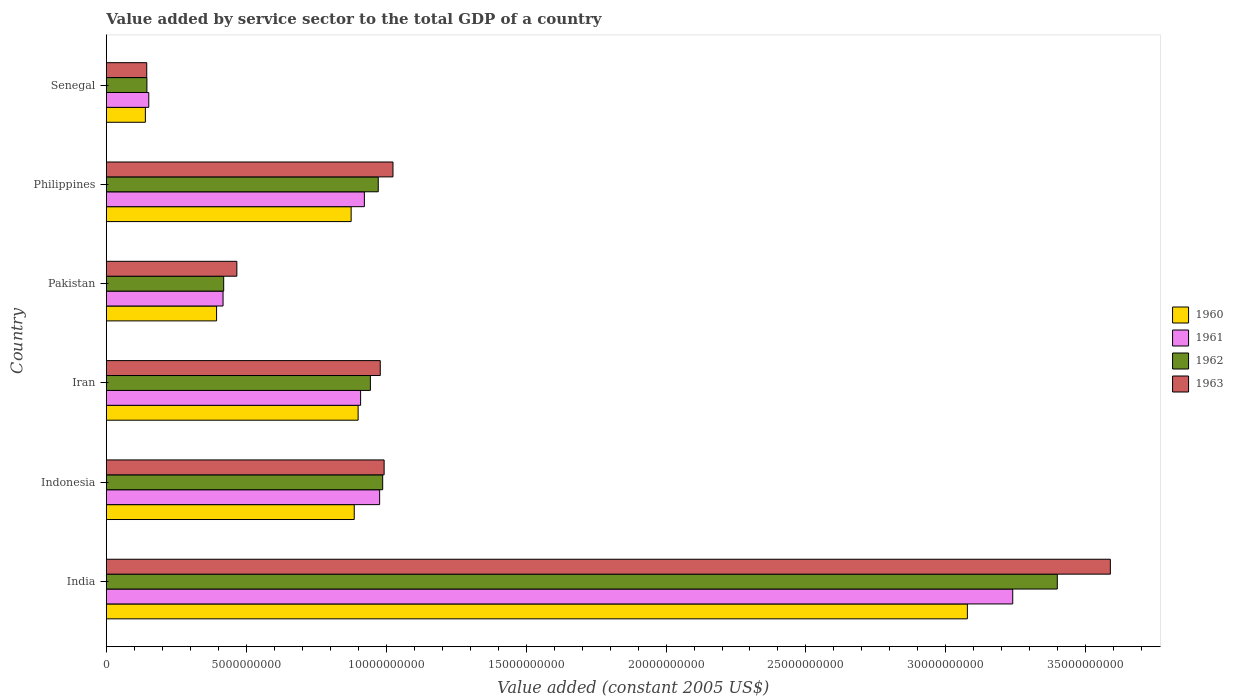How many different coloured bars are there?
Your answer should be compact. 4. How many groups of bars are there?
Provide a short and direct response. 6. How many bars are there on the 6th tick from the top?
Keep it short and to the point. 4. What is the value added by service sector in 1962 in Philippines?
Your response must be concise. 9.72e+09. Across all countries, what is the maximum value added by service sector in 1960?
Offer a very short reply. 3.08e+1. Across all countries, what is the minimum value added by service sector in 1962?
Provide a succinct answer. 1.45e+09. In which country was the value added by service sector in 1963 minimum?
Provide a succinct answer. Senegal. What is the total value added by service sector in 1961 in the graph?
Make the answer very short. 6.62e+1. What is the difference between the value added by service sector in 1960 in Iran and that in Philippines?
Provide a succinct answer. 2.49e+08. What is the difference between the value added by service sector in 1963 in India and the value added by service sector in 1961 in Pakistan?
Offer a very short reply. 3.17e+1. What is the average value added by service sector in 1962 per country?
Your response must be concise. 1.14e+1. What is the difference between the value added by service sector in 1962 and value added by service sector in 1963 in Iran?
Give a very brief answer. -3.52e+08. In how many countries, is the value added by service sector in 1962 greater than 2000000000 US$?
Offer a very short reply. 5. What is the ratio of the value added by service sector in 1961 in Philippines to that in Senegal?
Provide a short and direct response. 6.08. What is the difference between the highest and the second highest value added by service sector in 1961?
Make the answer very short. 2.26e+1. What is the difference between the highest and the lowest value added by service sector in 1962?
Your response must be concise. 3.25e+1. Is it the case that in every country, the sum of the value added by service sector in 1963 and value added by service sector in 1960 is greater than the value added by service sector in 1961?
Your response must be concise. Yes. What is the difference between two consecutive major ticks on the X-axis?
Ensure brevity in your answer.  5.00e+09. Does the graph contain grids?
Give a very brief answer. No. How many legend labels are there?
Your response must be concise. 4. What is the title of the graph?
Your answer should be compact. Value added by service sector to the total GDP of a country. Does "2004" appear as one of the legend labels in the graph?
Give a very brief answer. No. What is the label or title of the X-axis?
Offer a terse response. Value added (constant 2005 US$). What is the label or title of the Y-axis?
Offer a very short reply. Country. What is the Value added (constant 2005 US$) of 1960 in India?
Give a very brief answer. 3.08e+1. What is the Value added (constant 2005 US$) of 1961 in India?
Provide a succinct answer. 3.24e+1. What is the Value added (constant 2005 US$) in 1962 in India?
Provide a short and direct response. 3.40e+1. What is the Value added (constant 2005 US$) of 1963 in India?
Provide a succinct answer. 3.59e+1. What is the Value added (constant 2005 US$) of 1960 in Indonesia?
Offer a very short reply. 8.86e+09. What is the Value added (constant 2005 US$) of 1961 in Indonesia?
Your response must be concise. 9.77e+09. What is the Value added (constant 2005 US$) of 1962 in Indonesia?
Ensure brevity in your answer.  9.88e+09. What is the Value added (constant 2005 US$) of 1963 in Indonesia?
Provide a succinct answer. 9.93e+09. What is the Value added (constant 2005 US$) in 1960 in Iran?
Your answer should be very brief. 9.00e+09. What is the Value added (constant 2005 US$) in 1961 in Iran?
Offer a terse response. 9.09e+09. What is the Value added (constant 2005 US$) of 1962 in Iran?
Give a very brief answer. 9.44e+09. What is the Value added (constant 2005 US$) in 1963 in Iran?
Keep it short and to the point. 9.79e+09. What is the Value added (constant 2005 US$) in 1960 in Pakistan?
Keep it short and to the point. 3.94e+09. What is the Value added (constant 2005 US$) of 1961 in Pakistan?
Give a very brief answer. 4.17e+09. What is the Value added (constant 2005 US$) of 1962 in Pakistan?
Your answer should be compact. 4.19e+09. What is the Value added (constant 2005 US$) of 1963 in Pakistan?
Keep it short and to the point. 4.66e+09. What is the Value added (constant 2005 US$) of 1960 in Philippines?
Offer a very short reply. 8.75e+09. What is the Value added (constant 2005 US$) of 1961 in Philippines?
Ensure brevity in your answer.  9.22e+09. What is the Value added (constant 2005 US$) in 1962 in Philippines?
Offer a very short reply. 9.72e+09. What is the Value added (constant 2005 US$) of 1963 in Philippines?
Offer a terse response. 1.02e+1. What is the Value added (constant 2005 US$) in 1960 in Senegal?
Ensure brevity in your answer.  1.39e+09. What is the Value added (constant 2005 US$) in 1961 in Senegal?
Offer a terse response. 1.52e+09. What is the Value added (constant 2005 US$) in 1962 in Senegal?
Keep it short and to the point. 1.45e+09. What is the Value added (constant 2005 US$) in 1963 in Senegal?
Provide a succinct answer. 1.44e+09. Across all countries, what is the maximum Value added (constant 2005 US$) in 1960?
Make the answer very short. 3.08e+1. Across all countries, what is the maximum Value added (constant 2005 US$) of 1961?
Offer a very short reply. 3.24e+1. Across all countries, what is the maximum Value added (constant 2005 US$) in 1962?
Your response must be concise. 3.40e+1. Across all countries, what is the maximum Value added (constant 2005 US$) of 1963?
Make the answer very short. 3.59e+1. Across all countries, what is the minimum Value added (constant 2005 US$) in 1960?
Provide a succinct answer. 1.39e+09. Across all countries, what is the minimum Value added (constant 2005 US$) in 1961?
Ensure brevity in your answer.  1.52e+09. Across all countries, what is the minimum Value added (constant 2005 US$) of 1962?
Your answer should be compact. 1.45e+09. Across all countries, what is the minimum Value added (constant 2005 US$) in 1963?
Your answer should be compact. 1.44e+09. What is the total Value added (constant 2005 US$) of 1960 in the graph?
Offer a very short reply. 6.27e+1. What is the total Value added (constant 2005 US$) in 1961 in the graph?
Provide a succinct answer. 6.62e+1. What is the total Value added (constant 2005 US$) in 1962 in the graph?
Your answer should be very brief. 6.87e+1. What is the total Value added (constant 2005 US$) of 1963 in the graph?
Offer a terse response. 7.19e+1. What is the difference between the Value added (constant 2005 US$) in 1960 in India and that in Indonesia?
Your answer should be compact. 2.19e+1. What is the difference between the Value added (constant 2005 US$) in 1961 in India and that in Indonesia?
Your answer should be very brief. 2.26e+1. What is the difference between the Value added (constant 2005 US$) in 1962 in India and that in Indonesia?
Provide a succinct answer. 2.41e+1. What is the difference between the Value added (constant 2005 US$) in 1963 in India and that in Indonesia?
Provide a short and direct response. 2.60e+1. What is the difference between the Value added (constant 2005 US$) of 1960 in India and that in Iran?
Keep it short and to the point. 2.18e+1. What is the difference between the Value added (constant 2005 US$) of 1961 in India and that in Iran?
Your response must be concise. 2.33e+1. What is the difference between the Value added (constant 2005 US$) of 1962 in India and that in Iran?
Offer a very short reply. 2.45e+1. What is the difference between the Value added (constant 2005 US$) in 1963 in India and that in Iran?
Make the answer very short. 2.61e+1. What is the difference between the Value added (constant 2005 US$) of 1960 in India and that in Pakistan?
Your answer should be very brief. 2.68e+1. What is the difference between the Value added (constant 2005 US$) of 1961 in India and that in Pakistan?
Offer a very short reply. 2.82e+1. What is the difference between the Value added (constant 2005 US$) of 1962 in India and that in Pakistan?
Provide a succinct answer. 2.98e+1. What is the difference between the Value added (constant 2005 US$) in 1963 in India and that in Pakistan?
Offer a terse response. 3.12e+1. What is the difference between the Value added (constant 2005 US$) in 1960 in India and that in Philippines?
Your response must be concise. 2.20e+1. What is the difference between the Value added (constant 2005 US$) of 1961 in India and that in Philippines?
Your answer should be very brief. 2.32e+1. What is the difference between the Value added (constant 2005 US$) of 1962 in India and that in Philippines?
Ensure brevity in your answer.  2.43e+1. What is the difference between the Value added (constant 2005 US$) of 1963 in India and that in Philippines?
Provide a succinct answer. 2.56e+1. What is the difference between the Value added (constant 2005 US$) in 1960 in India and that in Senegal?
Offer a very short reply. 2.94e+1. What is the difference between the Value added (constant 2005 US$) in 1961 in India and that in Senegal?
Your answer should be very brief. 3.09e+1. What is the difference between the Value added (constant 2005 US$) in 1962 in India and that in Senegal?
Your response must be concise. 3.25e+1. What is the difference between the Value added (constant 2005 US$) in 1963 in India and that in Senegal?
Your answer should be compact. 3.44e+1. What is the difference between the Value added (constant 2005 US$) of 1960 in Indonesia and that in Iran?
Offer a very short reply. -1.39e+08. What is the difference between the Value added (constant 2005 US$) in 1961 in Indonesia and that in Iran?
Offer a very short reply. 6.80e+08. What is the difference between the Value added (constant 2005 US$) in 1962 in Indonesia and that in Iran?
Ensure brevity in your answer.  4.39e+08. What is the difference between the Value added (constant 2005 US$) in 1963 in Indonesia and that in Iran?
Your response must be concise. 1.38e+08. What is the difference between the Value added (constant 2005 US$) in 1960 in Indonesia and that in Pakistan?
Keep it short and to the point. 4.92e+09. What is the difference between the Value added (constant 2005 US$) in 1961 in Indonesia and that in Pakistan?
Your answer should be very brief. 5.60e+09. What is the difference between the Value added (constant 2005 US$) in 1962 in Indonesia and that in Pakistan?
Your answer should be very brief. 5.68e+09. What is the difference between the Value added (constant 2005 US$) of 1963 in Indonesia and that in Pakistan?
Ensure brevity in your answer.  5.26e+09. What is the difference between the Value added (constant 2005 US$) in 1960 in Indonesia and that in Philippines?
Your answer should be compact. 1.10e+08. What is the difference between the Value added (constant 2005 US$) in 1961 in Indonesia and that in Philippines?
Ensure brevity in your answer.  5.45e+08. What is the difference between the Value added (constant 2005 US$) of 1962 in Indonesia and that in Philippines?
Offer a terse response. 1.59e+08. What is the difference between the Value added (constant 2005 US$) of 1963 in Indonesia and that in Philippines?
Keep it short and to the point. -3.16e+08. What is the difference between the Value added (constant 2005 US$) in 1960 in Indonesia and that in Senegal?
Your response must be concise. 7.46e+09. What is the difference between the Value added (constant 2005 US$) in 1961 in Indonesia and that in Senegal?
Give a very brief answer. 8.25e+09. What is the difference between the Value added (constant 2005 US$) of 1962 in Indonesia and that in Senegal?
Provide a succinct answer. 8.43e+09. What is the difference between the Value added (constant 2005 US$) of 1963 in Indonesia and that in Senegal?
Your answer should be compact. 8.48e+09. What is the difference between the Value added (constant 2005 US$) in 1960 in Iran and that in Pakistan?
Offer a terse response. 5.06e+09. What is the difference between the Value added (constant 2005 US$) in 1961 in Iran and that in Pakistan?
Provide a succinct answer. 4.92e+09. What is the difference between the Value added (constant 2005 US$) of 1962 in Iran and that in Pakistan?
Offer a very short reply. 5.24e+09. What is the difference between the Value added (constant 2005 US$) of 1963 in Iran and that in Pakistan?
Provide a succinct answer. 5.12e+09. What is the difference between the Value added (constant 2005 US$) of 1960 in Iran and that in Philippines?
Your response must be concise. 2.49e+08. What is the difference between the Value added (constant 2005 US$) of 1961 in Iran and that in Philippines?
Your response must be concise. -1.35e+08. What is the difference between the Value added (constant 2005 US$) of 1962 in Iran and that in Philippines?
Offer a terse response. -2.80e+08. What is the difference between the Value added (constant 2005 US$) in 1963 in Iran and that in Philippines?
Offer a terse response. -4.54e+08. What is the difference between the Value added (constant 2005 US$) in 1960 in Iran and that in Senegal?
Keep it short and to the point. 7.60e+09. What is the difference between the Value added (constant 2005 US$) in 1961 in Iran and that in Senegal?
Provide a short and direct response. 7.57e+09. What is the difference between the Value added (constant 2005 US$) in 1962 in Iran and that in Senegal?
Keep it short and to the point. 7.99e+09. What is the difference between the Value added (constant 2005 US$) in 1963 in Iran and that in Senegal?
Offer a very short reply. 8.34e+09. What is the difference between the Value added (constant 2005 US$) in 1960 in Pakistan and that in Philippines?
Ensure brevity in your answer.  -4.81e+09. What is the difference between the Value added (constant 2005 US$) of 1961 in Pakistan and that in Philippines?
Provide a short and direct response. -5.05e+09. What is the difference between the Value added (constant 2005 US$) in 1962 in Pakistan and that in Philippines?
Your answer should be compact. -5.52e+09. What is the difference between the Value added (constant 2005 US$) in 1963 in Pakistan and that in Philippines?
Give a very brief answer. -5.58e+09. What is the difference between the Value added (constant 2005 US$) in 1960 in Pakistan and that in Senegal?
Provide a short and direct response. 2.54e+09. What is the difference between the Value added (constant 2005 US$) of 1961 in Pakistan and that in Senegal?
Offer a very short reply. 2.65e+09. What is the difference between the Value added (constant 2005 US$) in 1962 in Pakistan and that in Senegal?
Offer a very short reply. 2.74e+09. What is the difference between the Value added (constant 2005 US$) in 1963 in Pakistan and that in Senegal?
Your answer should be very brief. 3.22e+09. What is the difference between the Value added (constant 2005 US$) of 1960 in Philippines and that in Senegal?
Your answer should be compact. 7.35e+09. What is the difference between the Value added (constant 2005 US$) of 1961 in Philippines and that in Senegal?
Your response must be concise. 7.70e+09. What is the difference between the Value added (constant 2005 US$) of 1962 in Philippines and that in Senegal?
Ensure brevity in your answer.  8.27e+09. What is the difference between the Value added (constant 2005 US$) in 1963 in Philippines and that in Senegal?
Offer a terse response. 8.80e+09. What is the difference between the Value added (constant 2005 US$) in 1960 in India and the Value added (constant 2005 US$) in 1961 in Indonesia?
Make the answer very short. 2.10e+1. What is the difference between the Value added (constant 2005 US$) in 1960 in India and the Value added (constant 2005 US$) in 1962 in Indonesia?
Your response must be concise. 2.09e+1. What is the difference between the Value added (constant 2005 US$) in 1960 in India and the Value added (constant 2005 US$) in 1963 in Indonesia?
Offer a terse response. 2.08e+1. What is the difference between the Value added (constant 2005 US$) of 1961 in India and the Value added (constant 2005 US$) of 1962 in Indonesia?
Your response must be concise. 2.25e+1. What is the difference between the Value added (constant 2005 US$) of 1961 in India and the Value added (constant 2005 US$) of 1963 in Indonesia?
Offer a very short reply. 2.25e+1. What is the difference between the Value added (constant 2005 US$) in 1962 in India and the Value added (constant 2005 US$) in 1963 in Indonesia?
Offer a very short reply. 2.41e+1. What is the difference between the Value added (constant 2005 US$) of 1960 in India and the Value added (constant 2005 US$) of 1961 in Iran?
Provide a short and direct response. 2.17e+1. What is the difference between the Value added (constant 2005 US$) in 1960 in India and the Value added (constant 2005 US$) in 1962 in Iran?
Give a very brief answer. 2.13e+1. What is the difference between the Value added (constant 2005 US$) of 1960 in India and the Value added (constant 2005 US$) of 1963 in Iran?
Make the answer very short. 2.10e+1. What is the difference between the Value added (constant 2005 US$) of 1961 in India and the Value added (constant 2005 US$) of 1962 in Iran?
Offer a very short reply. 2.30e+1. What is the difference between the Value added (constant 2005 US$) in 1961 in India and the Value added (constant 2005 US$) in 1963 in Iran?
Your answer should be compact. 2.26e+1. What is the difference between the Value added (constant 2005 US$) of 1962 in India and the Value added (constant 2005 US$) of 1963 in Iran?
Ensure brevity in your answer.  2.42e+1. What is the difference between the Value added (constant 2005 US$) in 1960 in India and the Value added (constant 2005 US$) in 1961 in Pakistan?
Your response must be concise. 2.66e+1. What is the difference between the Value added (constant 2005 US$) in 1960 in India and the Value added (constant 2005 US$) in 1962 in Pakistan?
Make the answer very short. 2.66e+1. What is the difference between the Value added (constant 2005 US$) in 1960 in India and the Value added (constant 2005 US$) in 1963 in Pakistan?
Your response must be concise. 2.61e+1. What is the difference between the Value added (constant 2005 US$) in 1961 in India and the Value added (constant 2005 US$) in 1962 in Pakistan?
Keep it short and to the point. 2.82e+1. What is the difference between the Value added (constant 2005 US$) of 1961 in India and the Value added (constant 2005 US$) of 1963 in Pakistan?
Ensure brevity in your answer.  2.77e+1. What is the difference between the Value added (constant 2005 US$) in 1962 in India and the Value added (constant 2005 US$) in 1963 in Pakistan?
Offer a terse response. 2.93e+1. What is the difference between the Value added (constant 2005 US$) in 1960 in India and the Value added (constant 2005 US$) in 1961 in Philippines?
Your answer should be very brief. 2.15e+1. What is the difference between the Value added (constant 2005 US$) in 1960 in India and the Value added (constant 2005 US$) in 1962 in Philippines?
Provide a short and direct response. 2.11e+1. What is the difference between the Value added (constant 2005 US$) in 1960 in India and the Value added (constant 2005 US$) in 1963 in Philippines?
Provide a succinct answer. 2.05e+1. What is the difference between the Value added (constant 2005 US$) in 1961 in India and the Value added (constant 2005 US$) in 1962 in Philippines?
Keep it short and to the point. 2.27e+1. What is the difference between the Value added (constant 2005 US$) in 1961 in India and the Value added (constant 2005 US$) in 1963 in Philippines?
Offer a very short reply. 2.21e+1. What is the difference between the Value added (constant 2005 US$) of 1962 in India and the Value added (constant 2005 US$) of 1963 in Philippines?
Your answer should be very brief. 2.37e+1. What is the difference between the Value added (constant 2005 US$) in 1960 in India and the Value added (constant 2005 US$) in 1961 in Senegal?
Provide a succinct answer. 2.93e+1. What is the difference between the Value added (constant 2005 US$) in 1960 in India and the Value added (constant 2005 US$) in 1962 in Senegal?
Ensure brevity in your answer.  2.93e+1. What is the difference between the Value added (constant 2005 US$) in 1960 in India and the Value added (constant 2005 US$) in 1963 in Senegal?
Your response must be concise. 2.93e+1. What is the difference between the Value added (constant 2005 US$) of 1961 in India and the Value added (constant 2005 US$) of 1962 in Senegal?
Keep it short and to the point. 3.09e+1. What is the difference between the Value added (constant 2005 US$) of 1961 in India and the Value added (constant 2005 US$) of 1963 in Senegal?
Ensure brevity in your answer.  3.09e+1. What is the difference between the Value added (constant 2005 US$) in 1962 in India and the Value added (constant 2005 US$) in 1963 in Senegal?
Offer a very short reply. 3.25e+1. What is the difference between the Value added (constant 2005 US$) in 1960 in Indonesia and the Value added (constant 2005 US$) in 1961 in Iran?
Provide a succinct answer. -2.28e+08. What is the difference between the Value added (constant 2005 US$) of 1960 in Indonesia and the Value added (constant 2005 US$) of 1962 in Iran?
Ensure brevity in your answer.  -5.77e+08. What is the difference between the Value added (constant 2005 US$) in 1960 in Indonesia and the Value added (constant 2005 US$) in 1963 in Iran?
Provide a succinct answer. -9.30e+08. What is the difference between the Value added (constant 2005 US$) in 1961 in Indonesia and the Value added (constant 2005 US$) in 1962 in Iran?
Give a very brief answer. 3.30e+08. What is the difference between the Value added (constant 2005 US$) in 1961 in Indonesia and the Value added (constant 2005 US$) in 1963 in Iran?
Your answer should be compact. -2.20e+07. What is the difference between the Value added (constant 2005 US$) in 1962 in Indonesia and the Value added (constant 2005 US$) in 1963 in Iran?
Ensure brevity in your answer.  8.67e+07. What is the difference between the Value added (constant 2005 US$) in 1960 in Indonesia and the Value added (constant 2005 US$) in 1961 in Pakistan?
Give a very brief answer. 4.69e+09. What is the difference between the Value added (constant 2005 US$) of 1960 in Indonesia and the Value added (constant 2005 US$) of 1962 in Pakistan?
Make the answer very short. 4.66e+09. What is the difference between the Value added (constant 2005 US$) of 1960 in Indonesia and the Value added (constant 2005 US$) of 1963 in Pakistan?
Provide a short and direct response. 4.19e+09. What is the difference between the Value added (constant 2005 US$) of 1961 in Indonesia and the Value added (constant 2005 US$) of 1962 in Pakistan?
Your response must be concise. 5.57e+09. What is the difference between the Value added (constant 2005 US$) of 1961 in Indonesia and the Value added (constant 2005 US$) of 1963 in Pakistan?
Offer a terse response. 5.10e+09. What is the difference between the Value added (constant 2005 US$) of 1962 in Indonesia and the Value added (constant 2005 US$) of 1963 in Pakistan?
Your response must be concise. 5.21e+09. What is the difference between the Value added (constant 2005 US$) of 1960 in Indonesia and the Value added (constant 2005 US$) of 1961 in Philippines?
Your answer should be very brief. -3.63e+08. What is the difference between the Value added (constant 2005 US$) in 1960 in Indonesia and the Value added (constant 2005 US$) in 1962 in Philippines?
Offer a terse response. -8.58e+08. What is the difference between the Value added (constant 2005 US$) in 1960 in Indonesia and the Value added (constant 2005 US$) in 1963 in Philippines?
Your response must be concise. -1.38e+09. What is the difference between the Value added (constant 2005 US$) of 1961 in Indonesia and the Value added (constant 2005 US$) of 1962 in Philippines?
Offer a very short reply. 5.00e+07. What is the difference between the Value added (constant 2005 US$) in 1961 in Indonesia and the Value added (constant 2005 US$) in 1963 in Philippines?
Provide a short and direct response. -4.76e+08. What is the difference between the Value added (constant 2005 US$) in 1962 in Indonesia and the Value added (constant 2005 US$) in 1963 in Philippines?
Keep it short and to the point. -3.68e+08. What is the difference between the Value added (constant 2005 US$) in 1960 in Indonesia and the Value added (constant 2005 US$) in 1961 in Senegal?
Ensure brevity in your answer.  7.34e+09. What is the difference between the Value added (constant 2005 US$) in 1960 in Indonesia and the Value added (constant 2005 US$) in 1962 in Senegal?
Provide a succinct answer. 7.41e+09. What is the difference between the Value added (constant 2005 US$) in 1960 in Indonesia and the Value added (constant 2005 US$) in 1963 in Senegal?
Your response must be concise. 7.41e+09. What is the difference between the Value added (constant 2005 US$) of 1961 in Indonesia and the Value added (constant 2005 US$) of 1962 in Senegal?
Ensure brevity in your answer.  8.32e+09. What is the difference between the Value added (constant 2005 US$) of 1961 in Indonesia and the Value added (constant 2005 US$) of 1963 in Senegal?
Keep it short and to the point. 8.32e+09. What is the difference between the Value added (constant 2005 US$) in 1962 in Indonesia and the Value added (constant 2005 US$) in 1963 in Senegal?
Offer a terse response. 8.43e+09. What is the difference between the Value added (constant 2005 US$) of 1960 in Iran and the Value added (constant 2005 US$) of 1961 in Pakistan?
Provide a succinct answer. 4.83e+09. What is the difference between the Value added (constant 2005 US$) of 1960 in Iran and the Value added (constant 2005 US$) of 1962 in Pakistan?
Your response must be concise. 4.80e+09. What is the difference between the Value added (constant 2005 US$) in 1960 in Iran and the Value added (constant 2005 US$) in 1963 in Pakistan?
Offer a terse response. 4.33e+09. What is the difference between the Value added (constant 2005 US$) in 1961 in Iran and the Value added (constant 2005 US$) in 1962 in Pakistan?
Keep it short and to the point. 4.89e+09. What is the difference between the Value added (constant 2005 US$) of 1961 in Iran and the Value added (constant 2005 US$) of 1963 in Pakistan?
Ensure brevity in your answer.  4.42e+09. What is the difference between the Value added (constant 2005 US$) of 1962 in Iran and the Value added (constant 2005 US$) of 1963 in Pakistan?
Your answer should be compact. 4.77e+09. What is the difference between the Value added (constant 2005 US$) in 1960 in Iran and the Value added (constant 2005 US$) in 1961 in Philippines?
Offer a terse response. -2.24e+08. What is the difference between the Value added (constant 2005 US$) in 1960 in Iran and the Value added (constant 2005 US$) in 1962 in Philippines?
Provide a short and direct response. -7.19e+08. What is the difference between the Value added (constant 2005 US$) in 1960 in Iran and the Value added (constant 2005 US$) in 1963 in Philippines?
Make the answer very short. -1.25e+09. What is the difference between the Value added (constant 2005 US$) of 1961 in Iran and the Value added (constant 2005 US$) of 1962 in Philippines?
Your response must be concise. -6.30e+08. What is the difference between the Value added (constant 2005 US$) of 1961 in Iran and the Value added (constant 2005 US$) of 1963 in Philippines?
Make the answer very short. -1.16e+09. What is the difference between the Value added (constant 2005 US$) of 1962 in Iran and the Value added (constant 2005 US$) of 1963 in Philippines?
Offer a terse response. -8.07e+08. What is the difference between the Value added (constant 2005 US$) of 1960 in Iran and the Value added (constant 2005 US$) of 1961 in Senegal?
Offer a very short reply. 7.48e+09. What is the difference between the Value added (constant 2005 US$) of 1960 in Iran and the Value added (constant 2005 US$) of 1962 in Senegal?
Your answer should be compact. 7.55e+09. What is the difference between the Value added (constant 2005 US$) of 1960 in Iran and the Value added (constant 2005 US$) of 1963 in Senegal?
Offer a terse response. 7.55e+09. What is the difference between the Value added (constant 2005 US$) in 1961 in Iran and the Value added (constant 2005 US$) in 1962 in Senegal?
Your response must be concise. 7.64e+09. What is the difference between the Value added (constant 2005 US$) of 1961 in Iran and the Value added (constant 2005 US$) of 1963 in Senegal?
Provide a succinct answer. 7.64e+09. What is the difference between the Value added (constant 2005 US$) in 1962 in Iran and the Value added (constant 2005 US$) in 1963 in Senegal?
Make the answer very short. 7.99e+09. What is the difference between the Value added (constant 2005 US$) in 1960 in Pakistan and the Value added (constant 2005 US$) in 1961 in Philippines?
Keep it short and to the point. -5.28e+09. What is the difference between the Value added (constant 2005 US$) of 1960 in Pakistan and the Value added (constant 2005 US$) of 1962 in Philippines?
Give a very brief answer. -5.78e+09. What is the difference between the Value added (constant 2005 US$) in 1960 in Pakistan and the Value added (constant 2005 US$) in 1963 in Philippines?
Offer a very short reply. -6.30e+09. What is the difference between the Value added (constant 2005 US$) of 1961 in Pakistan and the Value added (constant 2005 US$) of 1962 in Philippines?
Provide a short and direct response. -5.55e+09. What is the difference between the Value added (constant 2005 US$) in 1961 in Pakistan and the Value added (constant 2005 US$) in 1963 in Philippines?
Offer a terse response. -6.07e+09. What is the difference between the Value added (constant 2005 US$) of 1962 in Pakistan and the Value added (constant 2005 US$) of 1963 in Philippines?
Give a very brief answer. -6.05e+09. What is the difference between the Value added (constant 2005 US$) of 1960 in Pakistan and the Value added (constant 2005 US$) of 1961 in Senegal?
Ensure brevity in your answer.  2.42e+09. What is the difference between the Value added (constant 2005 US$) in 1960 in Pakistan and the Value added (constant 2005 US$) in 1962 in Senegal?
Provide a succinct answer. 2.49e+09. What is the difference between the Value added (constant 2005 US$) in 1960 in Pakistan and the Value added (constant 2005 US$) in 1963 in Senegal?
Give a very brief answer. 2.49e+09. What is the difference between the Value added (constant 2005 US$) of 1961 in Pakistan and the Value added (constant 2005 US$) of 1962 in Senegal?
Provide a short and direct response. 2.72e+09. What is the difference between the Value added (constant 2005 US$) in 1961 in Pakistan and the Value added (constant 2005 US$) in 1963 in Senegal?
Your answer should be very brief. 2.73e+09. What is the difference between the Value added (constant 2005 US$) of 1962 in Pakistan and the Value added (constant 2005 US$) of 1963 in Senegal?
Provide a succinct answer. 2.75e+09. What is the difference between the Value added (constant 2005 US$) in 1960 in Philippines and the Value added (constant 2005 US$) in 1961 in Senegal?
Your answer should be very brief. 7.23e+09. What is the difference between the Value added (constant 2005 US$) of 1960 in Philippines and the Value added (constant 2005 US$) of 1962 in Senegal?
Give a very brief answer. 7.30e+09. What is the difference between the Value added (constant 2005 US$) of 1960 in Philippines and the Value added (constant 2005 US$) of 1963 in Senegal?
Make the answer very short. 7.30e+09. What is the difference between the Value added (constant 2005 US$) in 1961 in Philippines and the Value added (constant 2005 US$) in 1962 in Senegal?
Your answer should be very brief. 7.77e+09. What is the difference between the Value added (constant 2005 US$) of 1961 in Philippines and the Value added (constant 2005 US$) of 1963 in Senegal?
Your answer should be very brief. 7.78e+09. What is the difference between the Value added (constant 2005 US$) of 1962 in Philippines and the Value added (constant 2005 US$) of 1963 in Senegal?
Make the answer very short. 8.27e+09. What is the average Value added (constant 2005 US$) of 1960 per country?
Provide a succinct answer. 1.05e+1. What is the average Value added (constant 2005 US$) in 1961 per country?
Provide a short and direct response. 1.10e+1. What is the average Value added (constant 2005 US$) of 1962 per country?
Keep it short and to the point. 1.14e+1. What is the average Value added (constant 2005 US$) of 1963 per country?
Offer a very short reply. 1.20e+1. What is the difference between the Value added (constant 2005 US$) of 1960 and Value added (constant 2005 US$) of 1961 in India?
Your answer should be very brief. -1.62e+09. What is the difference between the Value added (constant 2005 US$) in 1960 and Value added (constant 2005 US$) in 1962 in India?
Your response must be concise. -3.21e+09. What is the difference between the Value added (constant 2005 US$) of 1960 and Value added (constant 2005 US$) of 1963 in India?
Provide a short and direct response. -5.11e+09. What is the difference between the Value added (constant 2005 US$) of 1961 and Value added (constant 2005 US$) of 1962 in India?
Offer a terse response. -1.59e+09. What is the difference between the Value added (constant 2005 US$) in 1961 and Value added (constant 2005 US$) in 1963 in India?
Make the answer very short. -3.49e+09. What is the difference between the Value added (constant 2005 US$) of 1962 and Value added (constant 2005 US$) of 1963 in India?
Provide a short and direct response. -1.90e+09. What is the difference between the Value added (constant 2005 US$) of 1960 and Value added (constant 2005 US$) of 1961 in Indonesia?
Offer a very short reply. -9.08e+08. What is the difference between the Value added (constant 2005 US$) of 1960 and Value added (constant 2005 US$) of 1962 in Indonesia?
Your answer should be compact. -1.02e+09. What is the difference between the Value added (constant 2005 US$) in 1960 and Value added (constant 2005 US$) in 1963 in Indonesia?
Provide a short and direct response. -1.07e+09. What is the difference between the Value added (constant 2005 US$) of 1961 and Value added (constant 2005 US$) of 1962 in Indonesia?
Keep it short and to the point. -1.09e+08. What is the difference between the Value added (constant 2005 US$) of 1961 and Value added (constant 2005 US$) of 1963 in Indonesia?
Your response must be concise. -1.60e+08. What is the difference between the Value added (constant 2005 US$) in 1962 and Value added (constant 2005 US$) in 1963 in Indonesia?
Offer a very short reply. -5.15e+07. What is the difference between the Value added (constant 2005 US$) in 1960 and Value added (constant 2005 US$) in 1961 in Iran?
Offer a very short reply. -8.88e+07. What is the difference between the Value added (constant 2005 US$) of 1960 and Value added (constant 2005 US$) of 1962 in Iran?
Make the answer very short. -4.39e+08. What is the difference between the Value added (constant 2005 US$) of 1960 and Value added (constant 2005 US$) of 1963 in Iran?
Offer a terse response. -7.91e+08. What is the difference between the Value added (constant 2005 US$) in 1961 and Value added (constant 2005 US$) in 1962 in Iran?
Your answer should be compact. -3.50e+08. What is the difference between the Value added (constant 2005 US$) in 1961 and Value added (constant 2005 US$) in 1963 in Iran?
Give a very brief answer. -7.02e+08. What is the difference between the Value added (constant 2005 US$) of 1962 and Value added (constant 2005 US$) of 1963 in Iran?
Keep it short and to the point. -3.52e+08. What is the difference between the Value added (constant 2005 US$) in 1960 and Value added (constant 2005 US$) in 1961 in Pakistan?
Provide a succinct answer. -2.32e+08. What is the difference between the Value added (constant 2005 US$) in 1960 and Value added (constant 2005 US$) in 1962 in Pakistan?
Provide a short and direct response. -2.54e+08. What is the difference between the Value added (constant 2005 US$) of 1960 and Value added (constant 2005 US$) of 1963 in Pakistan?
Offer a very short reply. -7.25e+08. What is the difference between the Value added (constant 2005 US$) in 1961 and Value added (constant 2005 US$) in 1962 in Pakistan?
Keep it short and to the point. -2.26e+07. What is the difference between the Value added (constant 2005 US$) in 1961 and Value added (constant 2005 US$) in 1963 in Pakistan?
Provide a succinct answer. -4.93e+08. What is the difference between the Value added (constant 2005 US$) in 1962 and Value added (constant 2005 US$) in 1963 in Pakistan?
Provide a succinct answer. -4.71e+08. What is the difference between the Value added (constant 2005 US$) in 1960 and Value added (constant 2005 US$) in 1961 in Philippines?
Make the answer very short. -4.73e+08. What is the difference between the Value added (constant 2005 US$) in 1960 and Value added (constant 2005 US$) in 1962 in Philippines?
Keep it short and to the point. -9.68e+08. What is the difference between the Value added (constant 2005 US$) of 1960 and Value added (constant 2005 US$) of 1963 in Philippines?
Keep it short and to the point. -1.49e+09. What is the difference between the Value added (constant 2005 US$) of 1961 and Value added (constant 2005 US$) of 1962 in Philippines?
Your answer should be very brief. -4.95e+08. What is the difference between the Value added (constant 2005 US$) of 1961 and Value added (constant 2005 US$) of 1963 in Philippines?
Your answer should be very brief. -1.02e+09. What is the difference between the Value added (constant 2005 US$) in 1962 and Value added (constant 2005 US$) in 1963 in Philippines?
Ensure brevity in your answer.  -5.27e+08. What is the difference between the Value added (constant 2005 US$) in 1960 and Value added (constant 2005 US$) in 1961 in Senegal?
Provide a short and direct response. -1.22e+08. What is the difference between the Value added (constant 2005 US$) of 1960 and Value added (constant 2005 US$) of 1962 in Senegal?
Offer a very short reply. -5.52e+07. What is the difference between the Value added (constant 2005 US$) of 1960 and Value added (constant 2005 US$) of 1963 in Senegal?
Offer a terse response. -4.94e+07. What is the difference between the Value added (constant 2005 US$) in 1961 and Value added (constant 2005 US$) in 1962 in Senegal?
Provide a short and direct response. 6.67e+07. What is the difference between the Value added (constant 2005 US$) of 1961 and Value added (constant 2005 US$) of 1963 in Senegal?
Give a very brief answer. 7.25e+07. What is the difference between the Value added (constant 2005 US$) of 1962 and Value added (constant 2005 US$) of 1963 in Senegal?
Your answer should be compact. 5.77e+06. What is the ratio of the Value added (constant 2005 US$) of 1960 in India to that in Indonesia?
Provide a succinct answer. 3.47. What is the ratio of the Value added (constant 2005 US$) in 1961 in India to that in Indonesia?
Offer a terse response. 3.32. What is the ratio of the Value added (constant 2005 US$) in 1962 in India to that in Indonesia?
Your response must be concise. 3.44. What is the ratio of the Value added (constant 2005 US$) in 1963 in India to that in Indonesia?
Give a very brief answer. 3.61. What is the ratio of the Value added (constant 2005 US$) in 1960 in India to that in Iran?
Your response must be concise. 3.42. What is the ratio of the Value added (constant 2005 US$) in 1961 in India to that in Iran?
Offer a very short reply. 3.56. What is the ratio of the Value added (constant 2005 US$) of 1962 in India to that in Iran?
Your answer should be very brief. 3.6. What is the ratio of the Value added (constant 2005 US$) in 1963 in India to that in Iran?
Offer a terse response. 3.67. What is the ratio of the Value added (constant 2005 US$) of 1960 in India to that in Pakistan?
Your response must be concise. 7.81. What is the ratio of the Value added (constant 2005 US$) in 1961 in India to that in Pakistan?
Keep it short and to the point. 7.77. What is the ratio of the Value added (constant 2005 US$) in 1962 in India to that in Pakistan?
Keep it short and to the point. 8.1. What is the ratio of the Value added (constant 2005 US$) of 1963 in India to that in Pakistan?
Keep it short and to the point. 7.69. What is the ratio of the Value added (constant 2005 US$) in 1960 in India to that in Philippines?
Your answer should be compact. 3.52. What is the ratio of the Value added (constant 2005 US$) in 1961 in India to that in Philippines?
Your answer should be very brief. 3.51. What is the ratio of the Value added (constant 2005 US$) of 1962 in India to that in Philippines?
Offer a very short reply. 3.5. What is the ratio of the Value added (constant 2005 US$) of 1963 in India to that in Philippines?
Give a very brief answer. 3.5. What is the ratio of the Value added (constant 2005 US$) in 1960 in India to that in Senegal?
Your answer should be compact. 22.06. What is the ratio of the Value added (constant 2005 US$) in 1961 in India to that in Senegal?
Your answer should be very brief. 21.35. What is the ratio of the Value added (constant 2005 US$) of 1962 in India to that in Senegal?
Offer a terse response. 23.43. What is the ratio of the Value added (constant 2005 US$) in 1963 in India to that in Senegal?
Make the answer very short. 24.84. What is the ratio of the Value added (constant 2005 US$) in 1960 in Indonesia to that in Iran?
Your response must be concise. 0.98. What is the ratio of the Value added (constant 2005 US$) in 1961 in Indonesia to that in Iran?
Offer a terse response. 1.07. What is the ratio of the Value added (constant 2005 US$) in 1962 in Indonesia to that in Iran?
Keep it short and to the point. 1.05. What is the ratio of the Value added (constant 2005 US$) of 1963 in Indonesia to that in Iran?
Provide a short and direct response. 1.01. What is the ratio of the Value added (constant 2005 US$) of 1960 in Indonesia to that in Pakistan?
Offer a terse response. 2.25. What is the ratio of the Value added (constant 2005 US$) in 1961 in Indonesia to that in Pakistan?
Your response must be concise. 2.34. What is the ratio of the Value added (constant 2005 US$) in 1962 in Indonesia to that in Pakistan?
Give a very brief answer. 2.35. What is the ratio of the Value added (constant 2005 US$) of 1963 in Indonesia to that in Pakistan?
Make the answer very short. 2.13. What is the ratio of the Value added (constant 2005 US$) in 1960 in Indonesia to that in Philippines?
Offer a terse response. 1.01. What is the ratio of the Value added (constant 2005 US$) of 1961 in Indonesia to that in Philippines?
Keep it short and to the point. 1.06. What is the ratio of the Value added (constant 2005 US$) in 1962 in Indonesia to that in Philippines?
Make the answer very short. 1.02. What is the ratio of the Value added (constant 2005 US$) of 1963 in Indonesia to that in Philippines?
Your answer should be compact. 0.97. What is the ratio of the Value added (constant 2005 US$) in 1960 in Indonesia to that in Senegal?
Offer a terse response. 6.35. What is the ratio of the Value added (constant 2005 US$) of 1961 in Indonesia to that in Senegal?
Ensure brevity in your answer.  6.44. What is the ratio of the Value added (constant 2005 US$) in 1962 in Indonesia to that in Senegal?
Your response must be concise. 6.81. What is the ratio of the Value added (constant 2005 US$) of 1963 in Indonesia to that in Senegal?
Keep it short and to the point. 6.87. What is the ratio of the Value added (constant 2005 US$) in 1960 in Iran to that in Pakistan?
Keep it short and to the point. 2.28. What is the ratio of the Value added (constant 2005 US$) in 1961 in Iran to that in Pakistan?
Keep it short and to the point. 2.18. What is the ratio of the Value added (constant 2005 US$) of 1962 in Iran to that in Pakistan?
Offer a terse response. 2.25. What is the ratio of the Value added (constant 2005 US$) in 1963 in Iran to that in Pakistan?
Your answer should be compact. 2.1. What is the ratio of the Value added (constant 2005 US$) of 1960 in Iran to that in Philippines?
Offer a terse response. 1.03. What is the ratio of the Value added (constant 2005 US$) of 1961 in Iran to that in Philippines?
Provide a short and direct response. 0.99. What is the ratio of the Value added (constant 2005 US$) of 1962 in Iran to that in Philippines?
Your response must be concise. 0.97. What is the ratio of the Value added (constant 2005 US$) in 1963 in Iran to that in Philippines?
Provide a short and direct response. 0.96. What is the ratio of the Value added (constant 2005 US$) of 1960 in Iran to that in Senegal?
Provide a short and direct response. 6.45. What is the ratio of the Value added (constant 2005 US$) of 1961 in Iran to that in Senegal?
Keep it short and to the point. 5.99. What is the ratio of the Value added (constant 2005 US$) in 1962 in Iran to that in Senegal?
Your response must be concise. 6.51. What is the ratio of the Value added (constant 2005 US$) in 1963 in Iran to that in Senegal?
Your answer should be compact. 6.78. What is the ratio of the Value added (constant 2005 US$) of 1960 in Pakistan to that in Philippines?
Keep it short and to the point. 0.45. What is the ratio of the Value added (constant 2005 US$) of 1961 in Pakistan to that in Philippines?
Keep it short and to the point. 0.45. What is the ratio of the Value added (constant 2005 US$) in 1962 in Pakistan to that in Philippines?
Your answer should be compact. 0.43. What is the ratio of the Value added (constant 2005 US$) in 1963 in Pakistan to that in Philippines?
Make the answer very short. 0.46. What is the ratio of the Value added (constant 2005 US$) of 1960 in Pakistan to that in Senegal?
Offer a terse response. 2.82. What is the ratio of the Value added (constant 2005 US$) of 1961 in Pakistan to that in Senegal?
Keep it short and to the point. 2.75. What is the ratio of the Value added (constant 2005 US$) of 1962 in Pakistan to that in Senegal?
Your response must be concise. 2.89. What is the ratio of the Value added (constant 2005 US$) in 1963 in Pakistan to that in Senegal?
Your response must be concise. 3.23. What is the ratio of the Value added (constant 2005 US$) in 1960 in Philippines to that in Senegal?
Provide a short and direct response. 6.27. What is the ratio of the Value added (constant 2005 US$) in 1961 in Philippines to that in Senegal?
Provide a succinct answer. 6.08. What is the ratio of the Value added (constant 2005 US$) of 1962 in Philippines to that in Senegal?
Ensure brevity in your answer.  6.7. What is the ratio of the Value added (constant 2005 US$) of 1963 in Philippines to that in Senegal?
Make the answer very short. 7.09. What is the difference between the highest and the second highest Value added (constant 2005 US$) of 1960?
Your answer should be very brief. 2.18e+1. What is the difference between the highest and the second highest Value added (constant 2005 US$) of 1961?
Offer a terse response. 2.26e+1. What is the difference between the highest and the second highest Value added (constant 2005 US$) of 1962?
Your answer should be compact. 2.41e+1. What is the difference between the highest and the second highest Value added (constant 2005 US$) in 1963?
Ensure brevity in your answer.  2.56e+1. What is the difference between the highest and the lowest Value added (constant 2005 US$) in 1960?
Your answer should be compact. 2.94e+1. What is the difference between the highest and the lowest Value added (constant 2005 US$) of 1961?
Offer a terse response. 3.09e+1. What is the difference between the highest and the lowest Value added (constant 2005 US$) of 1962?
Make the answer very short. 3.25e+1. What is the difference between the highest and the lowest Value added (constant 2005 US$) of 1963?
Make the answer very short. 3.44e+1. 